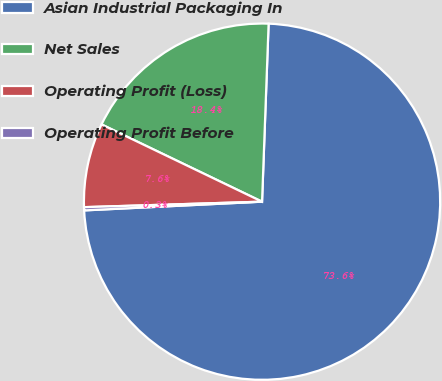<chart> <loc_0><loc_0><loc_500><loc_500><pie_chart><fcel>Asian Industrial Packaging In<fcel>Net Sales<fcel>Operating Profit (Loss)<fcel>Operating Profit Before<nl><fcel>73.64%<fcel>18.45%<fcel>7.63%<fcel>0.29%<nl></chart> 